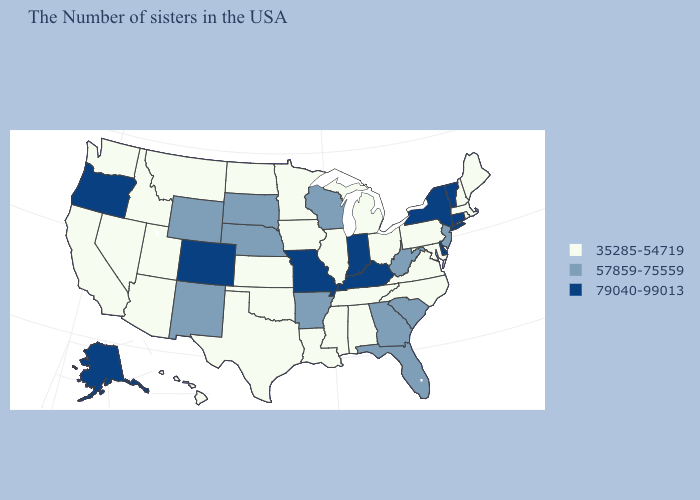Among the states that border Connecticut , which have the highest value?
Concise answer only. New York. What is the highest value in the MidWest ?
Write a very short answer. 79040-99013. Among the states that border Florida , which have the lowest value?
Be succinct. Alabama. What is the lowest value in the West?
Short answer required. 35285-54719. Does West Virginia have the lowest value in the South?
Write a very short answer. No. Name the states that have a value in the range 79040-99013?
Keep it brief. Vermont, Connecticut, New York, Delaware, Kentucky, Indiana, Missouri, Colorado, Oregon, Alaska. Name the states that have a value in the range 35285-54719?
Write a very short answer. Maine, Massachusetts, Rhode Island, New Hampshire, Maryland, Pennsylvania, Virginia, North Carolina, Ohio, Michigan, Alabama, Tennessee, Illinois, Mississippi, Louisiana, Minnesota, Iowa, Kansas, Oklahoma, Texas, North Dakota, Utah, Montana, Arizona, Idaho, Nevada, California, Washington, Hawaii. What is the lowest value in states that border Connecticut?
Answer briefly. 35285-54719. What is the lowest value in states that border Wyoming?
Answer briefly. 35285-54719. Does Kentucky have the highest value in the South?
Answer briefly. Yes. Does the first symbol in the legend represent the smallest category?
Concise answer only. Yes. Is the legend a continuous bar?
Short answer required. No. Does Utah have the same value as South Carolina?
Quick response, please. No. Among the states that border Arkansas , which have the lowest value?
Keep it brief. Tennessee, Mississippi, Louisiana, Oklahoma, Texas. 